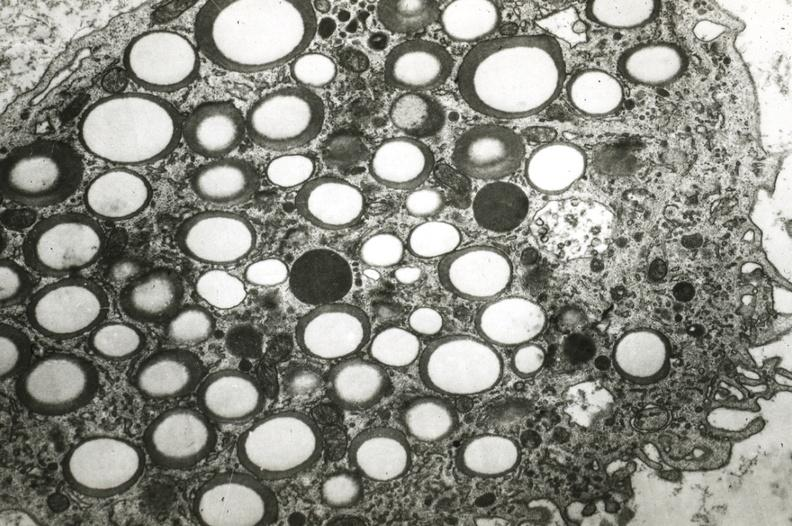s polycystic disease present?
Answer the question using a single word or phrase. No 